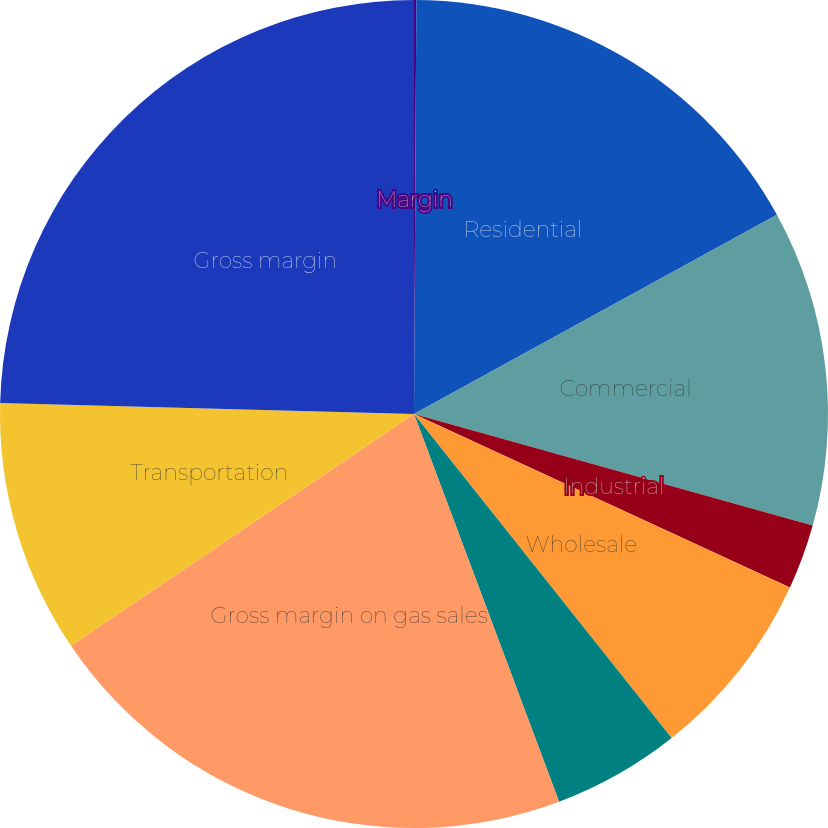Convert chart. <chart><loc_0><loc_0><loc_500><loc_500><pie_chart><fcel>Margin<fcel>Residential<fcel>Commercial<fcel>Industrial<fcel>Wholesale<fcel>Public Authority<fcel>Gross margin on gas sales<fcel>Transportation<fcel>Gross margin<nl><fcel>0.09%<fcel>16.92%<fcel>12.33%<fcel>2.54%<fcel>7.43%<fcel>4.99%<fcel>21.24%<fcel>9.88%<fcel>24.58%<nl></chart> 